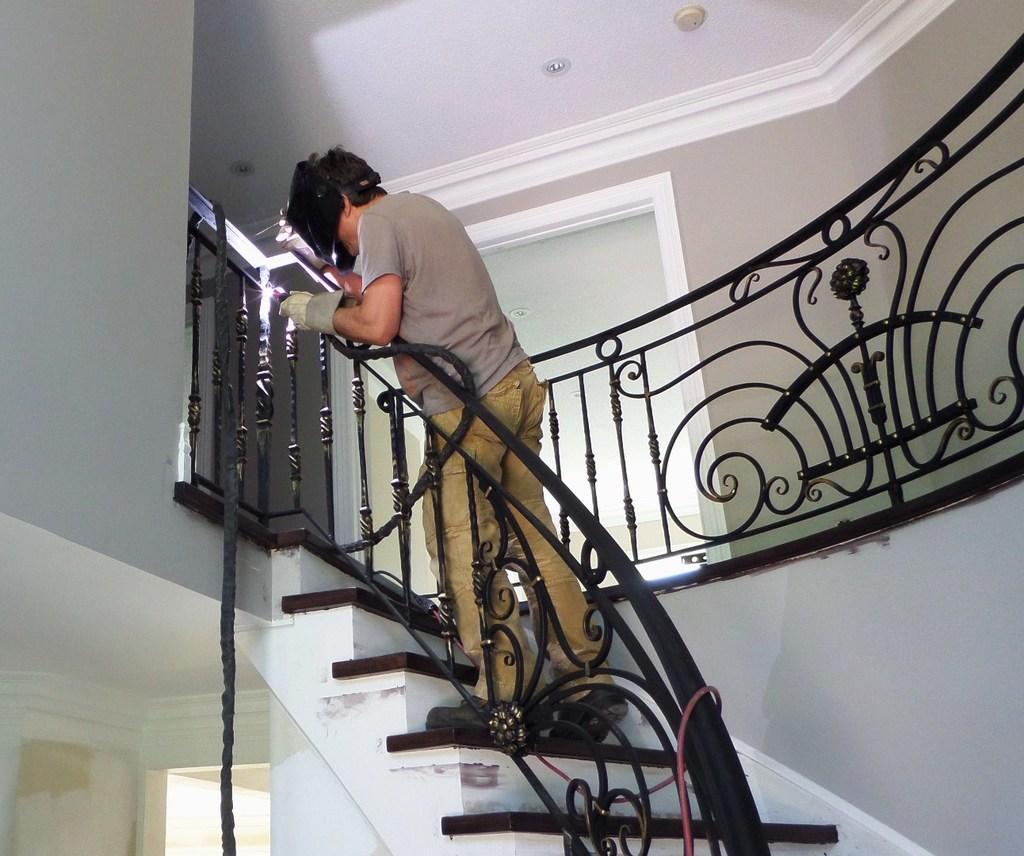In one or two sentences, can you explain what this image depicts? This image is taken indoors. In this image there are a few walls with a window. At the top of the image there is a ceiling. In the middle of the image there is a staircase with a railing and a man is standing on the stairs and he is holding a pipe in his hand. 